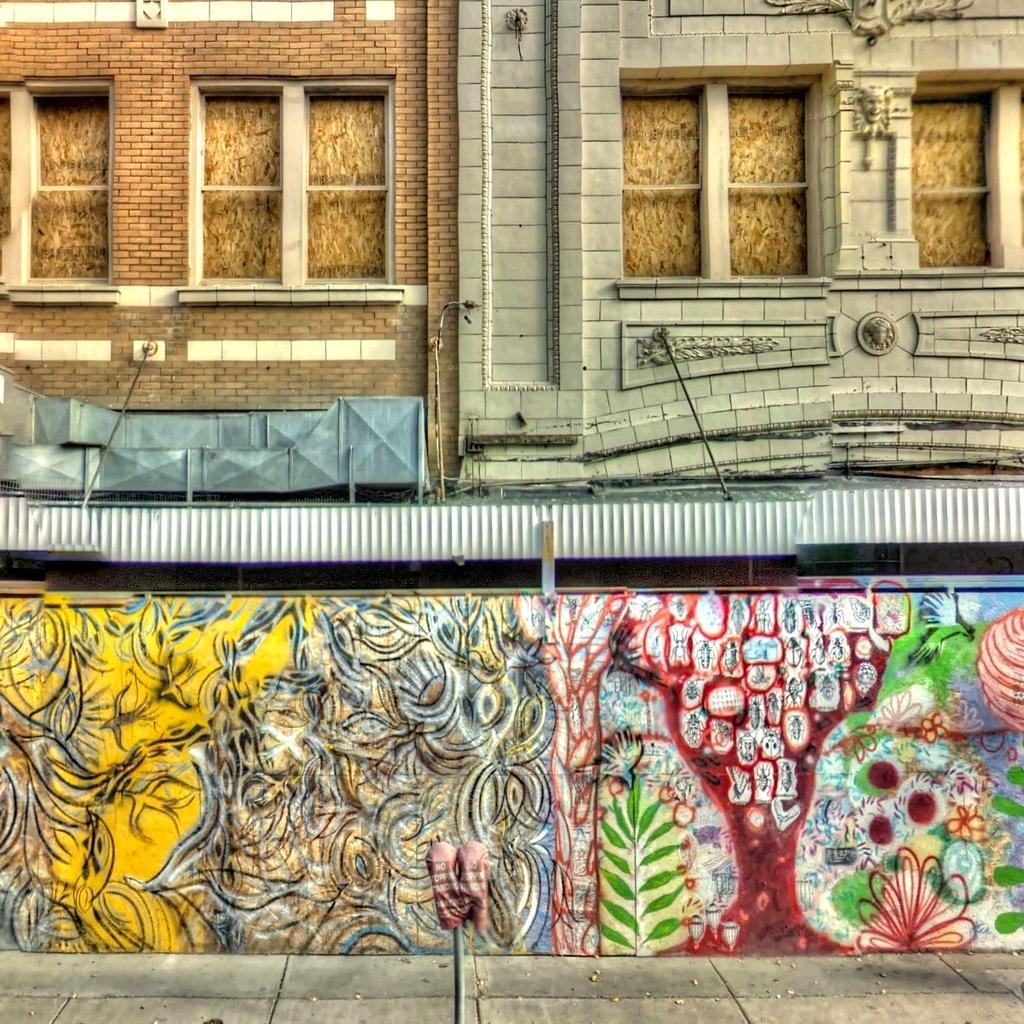Can you describe this image briefly? In the center of the image we can see a wall. On wall graffiti is there. At the top of the image wall, windows are there. At the bottom of the image ground is there. 